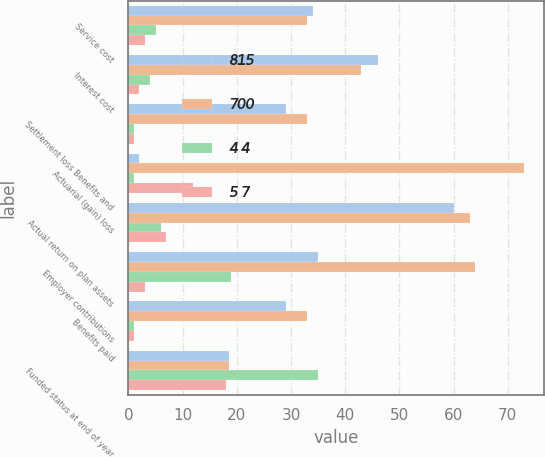Convert chart to OTSL. <chart><loc_0><loc_0><loc_500><loc_500><stacked_bar_chart><ecel><fcel>Service cost<fcel>Interest cost<fcel>Settlement loss Benefits and<fcel>Actuarial (gain) loss<fcel>Actual return on plan assets<fcel>Employer contributions<fcel>Benefits paid<fcel>Funded status at end of year<nl><fcel>815<fcel>34<fcel>46<fcel>29<fcel>2<fcel>60<fcel>35<fcel>29<fcel>18.5<nl><fcel>700<fcel>33<fcel>43<fcel>33<fcel>73<fcel>63<fcel>64<fcel>33<fcel>18.5<nl><fcel>4 4<fcel>5<fcel>4<fcel>1<fcel>1<fcel>6<fcel>19<fcel>1<fcel>35<nl><fcel>5 7<fcel>3<fcel>2<fcel>1<fcel>12<fcel>7<fcel>3<fcel>1<fcel>18<nl></chart> 